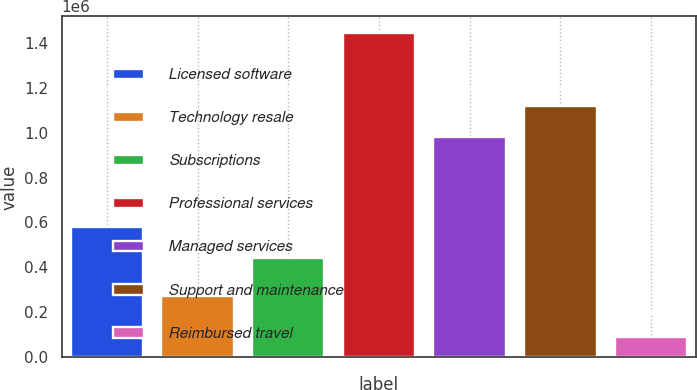<chart> <loc_0><loc_0><loc_500><loc_500><bar_chart><fcel>Licensed software<fcel>Technology resale<fcel>Subscriptions<fcel>Professional services<fcel>Managed services<fcel>Support and maintenance<fcel>Reimbursed travel<nl><fcel>577971<fcel>274475<fcel>442368<fcel>1.44458e+06<fcel>981577<fcel>1.11718e+06<fcel>88545<nl></chart> 